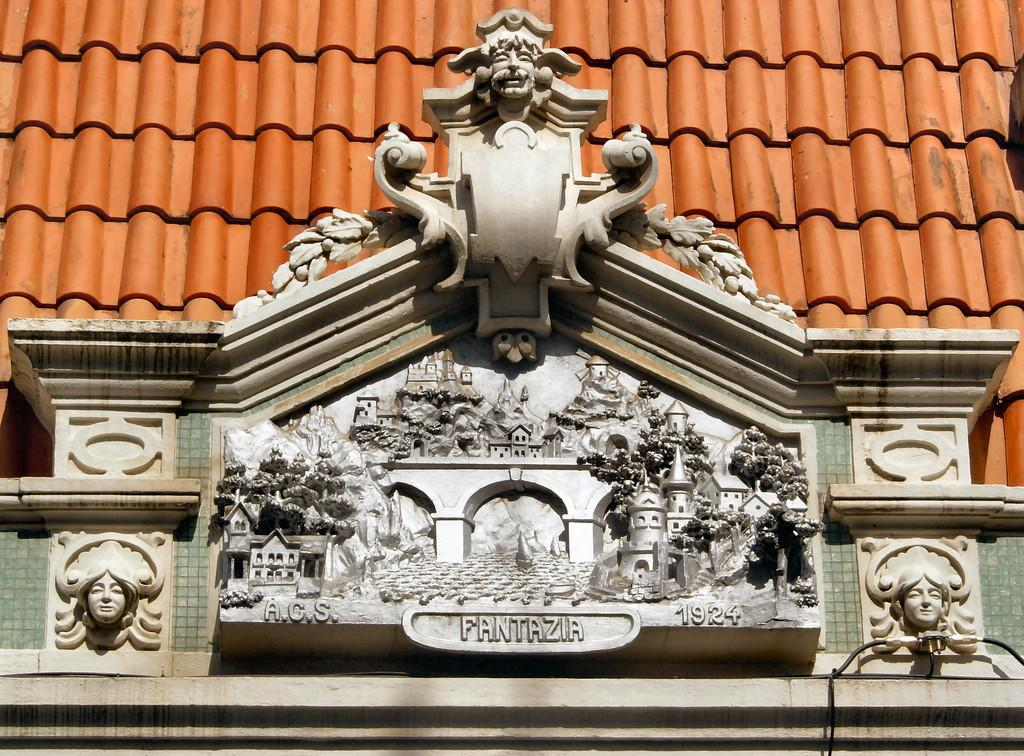What is the main subject of the image? The main subject of the image is a carving. Can you describe the setting of the image? The roof of a building is visible in the image. What type of insurance is being discussed in the image? There is no discussion of insurance in the image; it features a carving and the roof of a building. What kind of feast is being held in the image? There is no feast present in the image; it only shows a carving and the roof of a building. 